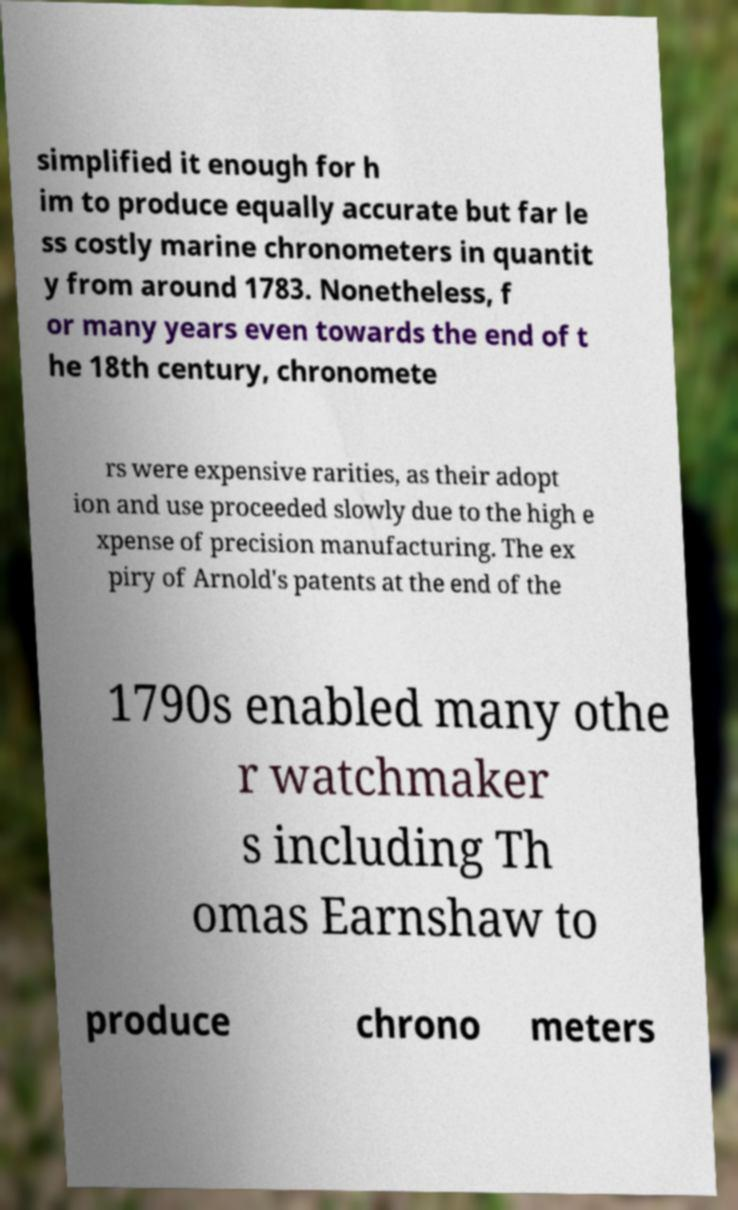Can you read and provide the text displayed in the image?This photo seems to have some interesting text. Can you extract and type it out for me? simplified it enough for h im to produce equally accurate but far le ss costly marine chronometers in quantit y from around 1783. Nonetheless, f or many years even towards the end of t he 18th century, chronomete rs were expensive rarities, as their adopt ion and use proceeded slowly due to the high e xpense of precision manufacturing. The ex piry of Arnold's patents at the end of the 1790s enabled many othe r watchmaker s including Th omas Earnshaw to produce chrono meters 